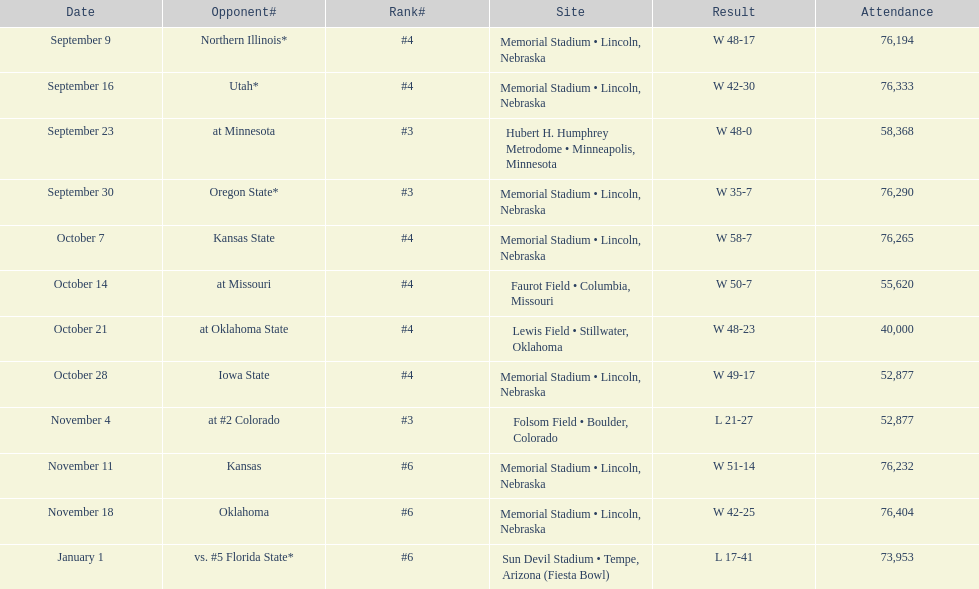Which month appears the least frequently on this chart? January. 